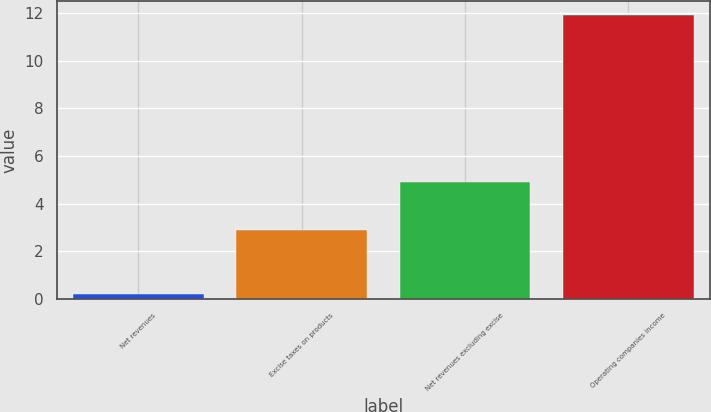Convert chart to OTSL. <chart><loc_0><loc_0><loc_500><loc_500><bar_chart><fcel>Net revenues<fcel>Excise taxes on products<fcel>Net revenues excluding excise<fcel>Operating companies income<nl><fcel>0.2<fcel>2.9<fcel>4.9<fcel>11.9<nl></chart> 